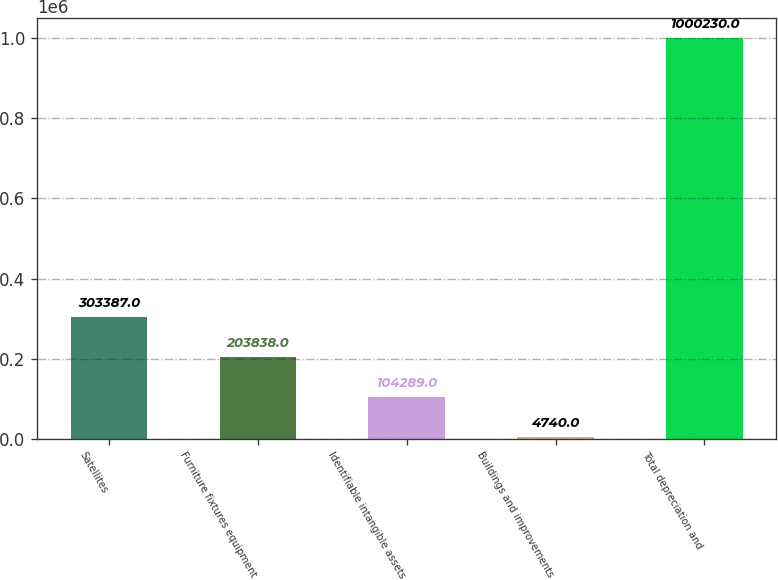Convert chart to OTSL. <chart><loc_0><loc_0><loc_500><loc_500><bar_chart><fcel>Satellites<fcel>Furniture fixtures equipment<fcel>Identifiable intangible assets<fcel>Buildings and improvements<fcel>Total depreciation and<nl><fcel>303387<fcel>203838<fcel>104289<fcel>4740<fcel>1.00023e+06<nl></chart> 